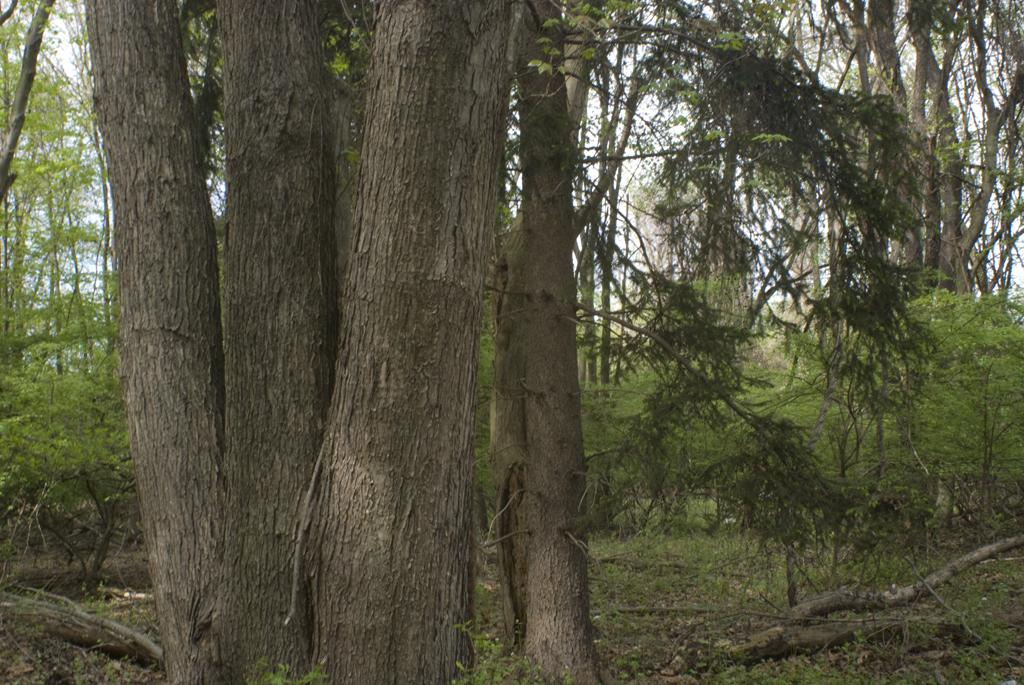What is the main subject in the image? There is a tree trunk in the image. What can be seen behind the tree trunk? There are many tall trees behind the tree trunk in the image. What type of vegetation is present in the image besides the tall trees? There are plants in the image. What type of drink is being served in the image? There is no drink present in the image; it features a tree trunk and tall trees. What word is written on the tree trunk in the image? There are no words written on the tree trunk in the image. 